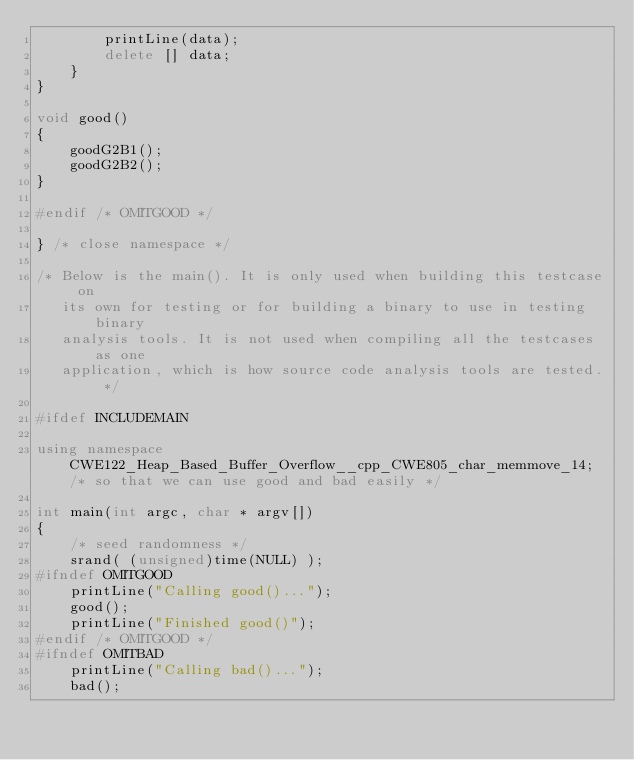<code> <loc_0><loc_0><loc_500><loc_500><_C++_>        printLine(data);
        delete [] data;
    }
}

void good()
{
    goodG2B1();
    goodG2B2();
}

#endif /* OMITGOOD */

} /* close namespace */

/* Below is the main(). It is only used when building this testcase on
   its own for testing or for building a binary to use in testing binary
   analysis tools. It is not used when compiling all the testcases as one
   application, which is how source code analysis tools are tested. */

#ifdef INCLUDEMAIN

using namespace CWE122_Heap_Based_Buffer_Overflow__cpp_CWE805_char_memmove_14; /* so that we can use good and bad easily */

int main(int argc, char * argv[])
{
    /* seed randomness */
    srand( (unsigned)time(NULL) );
#ifndef OMITGOOD
    printLine("Calling good()...");
    good();
    printLine("Finished good()");
#endif /* OMITGOOD */
#ifndef OMITBAD
    printLine("Calling bad()...");
    bad();</code> 